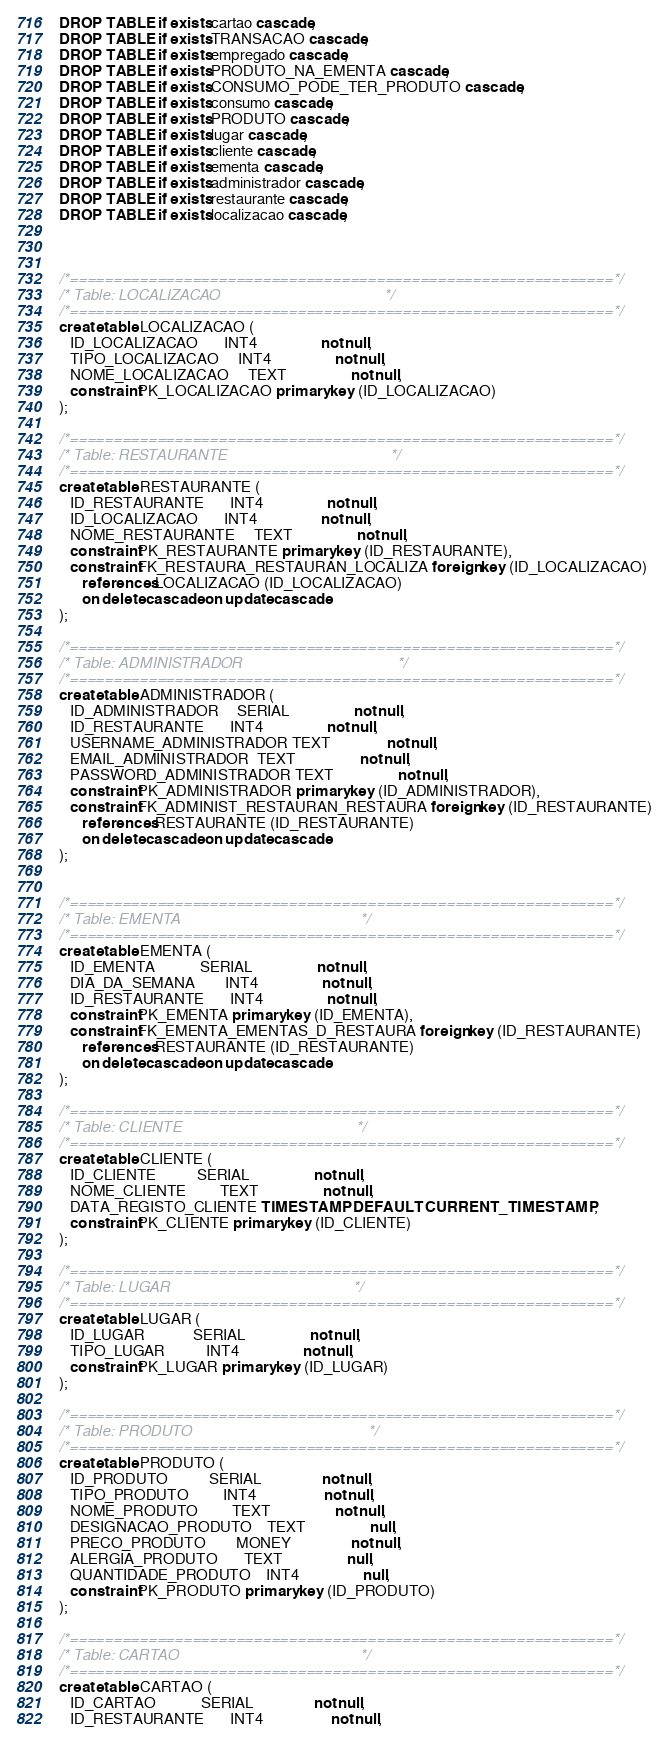Convert code to text. <code><loc_0><loc_0><loc_500><loc_500><_SQL_>DROP TABLE if exists cartao cascade;
DROP TABLE if exists TRANSACAO cascade;
DROP TABLE if exists empregado cascade;
DROP TABLE if exists PRODUTO_NA_EMENTA cascade; 
DROP TABLE if exists CONSUMO_PODE_TER_PRODUTO cascade;
DROP TABLE if exists consumo cascade; 
DROP TABLE if exists PRODUTO cascade; 
DROP TABLE if exists lugar cascade; 
DROP TABLE if exists cliente cascade; 
DROP TABLE if exists ementa cascade; 
DROP TABLE if exists administrador cascade; 
DROP TABLE if exists restaurante cascade; 
DROP TABLE if exists localizacao cascade; 



/*==============================================================*/
/* Table: LOCALIZACAO                                           */
/*==============================================================*/
create table LOCALIZACAO (
   ID_LOCALIZACAO       INT4                 not null,
   TIPO_LOCALIZACAO     INT4                 not null,
   NOME_LOCALIZACAO     TEXT                 not null,
   constraint PK_LOCALIZACAO primary key (ID_LOCALIZACAO)
);

/*==============================================================*/
/* Table: RESTAURANTE                                           */
/*==============================================================*/
create table RESTAURANTE (
   ID_RESTAURANTE       INT4                 not null,
   ID_LOCALIZACAO       INT4                 not null,
   NOME_RESTAURANTE     TEXT                 not null,
   constraint PK_RESTAURANTE primary key (ID_RESTAURANTE),
   constraint FK_RESTAURA_RESTAURAN_LOCALIZA foreign key (ID_LOCALIZACAO)
      references LOCALIZACAO (ID_LOCALIZACAO)
      on delete cascade on update cascade
);

/*==============================================================*/
/* Table: ADMINISTRADOR                                         */
/*==============================================================*/
create table ADMINISTRADOR (
   ID_ADMINISTRADOR     SERIAL                 not null,
   ID_RESTAURANTE       INT4                 not null,
   USERNAME_ADMINISTRADOR TEXT               not null,
   EMAIL_ADMINISTRADOR  TEXT                 not null,
   PASSWORD_ADMINISTRADOR TEXT                 not null,
   constraint PK_ADMINISTRADOR primary key (ID_ADMINISTRADOR),
   constraint FK_ADMINIST_RESTAURAN_RESTAURA foreign key (ID_RESTAURANTE)
      references RESTAURANTE (ID_RESTAURANTE)
      on delete cascade on update cascade
);


/*==============================================================*/
/* Table: EMENTA                                                */
/*==============================================================*/
create table EMENTA (
   ID_EMENTA            SERIAL                 not null,
   DIA_DA_SEMANA        INT4                 not null,
   ID_RESTAURANTE       INT4                 not null,
   constraint PK_EMENTA primary key (ID_EMENTA),
   constraint FK_EMENTA_EMENTAS_D_RESTAURA foreign key (ID_RESTAURANTE)
      references RESTAURANTE (ID_RESTAURANTE)
      on delete cascade on update cascade
);

/*==============================================================*/
/* Table: CLIENTE                                               */
/*==============================================================*/
create table CLIENTE (
   ID_CLIENTE           SERIAL                 not null,
   NOME_CLIENTE         TEXT                 not null,
   DATA_REGISTO_CLIENTE TIMESTAMP DEFAULT CURRENT_TIMESTAMP,
   constraint PK_CLIENTE primary key (ID_CLIENTE)
);

/*==============================================================*/
/* Table: LUGAR                                                 */
/*==============================================================*/
create table LUGAR (
   ID_LUGAR             SERIAL                 not null,
   TIPO_LUGAR           INT4                 not null,
   constraint PK_LUGAR primary key (ID_LUGAR)
);

/*==============================================================*/
/* Table: PRODUTO                                               */
/*==============================================================*/
create table PRODUTO (
   ID_PRODUTO           SERIAL                not null,
   TIPO_PRODUTO         INT4                  not null,
   NOME_PRODUTO         TEXT                 not null,
   DESIGNACAO_PRODUTO    TEXT                 null,
   PRECO_PRODUTO        MONEY                not null,
   ALERGIA_PRODUTO       TEXT                 null,
   QUANTIDADE_PRODUTO    INT4                 null,
   constraint PK_PRODUTO primary key (ID_PRODUTO)
);

/*==============================================================*/
/* Table: CARTAO                                                */
/*==============================================================*/
create table CARTAO (
   ID_CARTAO            SERIAL                not null,
   ID_RESTAURANTE       INT4                  not null,</code> 